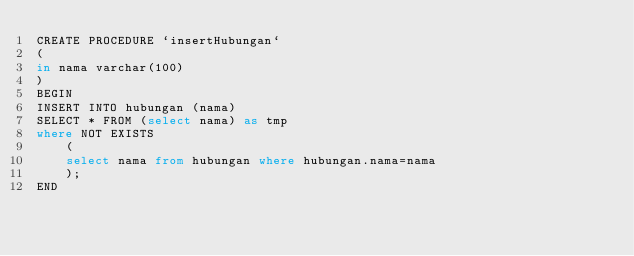<code> <loc_0><loc_0><loc_500><loc_500><_SQL_>CREATE PROCEDURE `insertHubungan` 
(
in nama varchar(100)
)
BEGIN
INSERT INTO hubungan (nama) 
SELECT * FROM (select nama) as tmp
where NOT EXISTS
	(
	select nama from hubungan where hubungan.nama=nama 
    );
END
</code> 